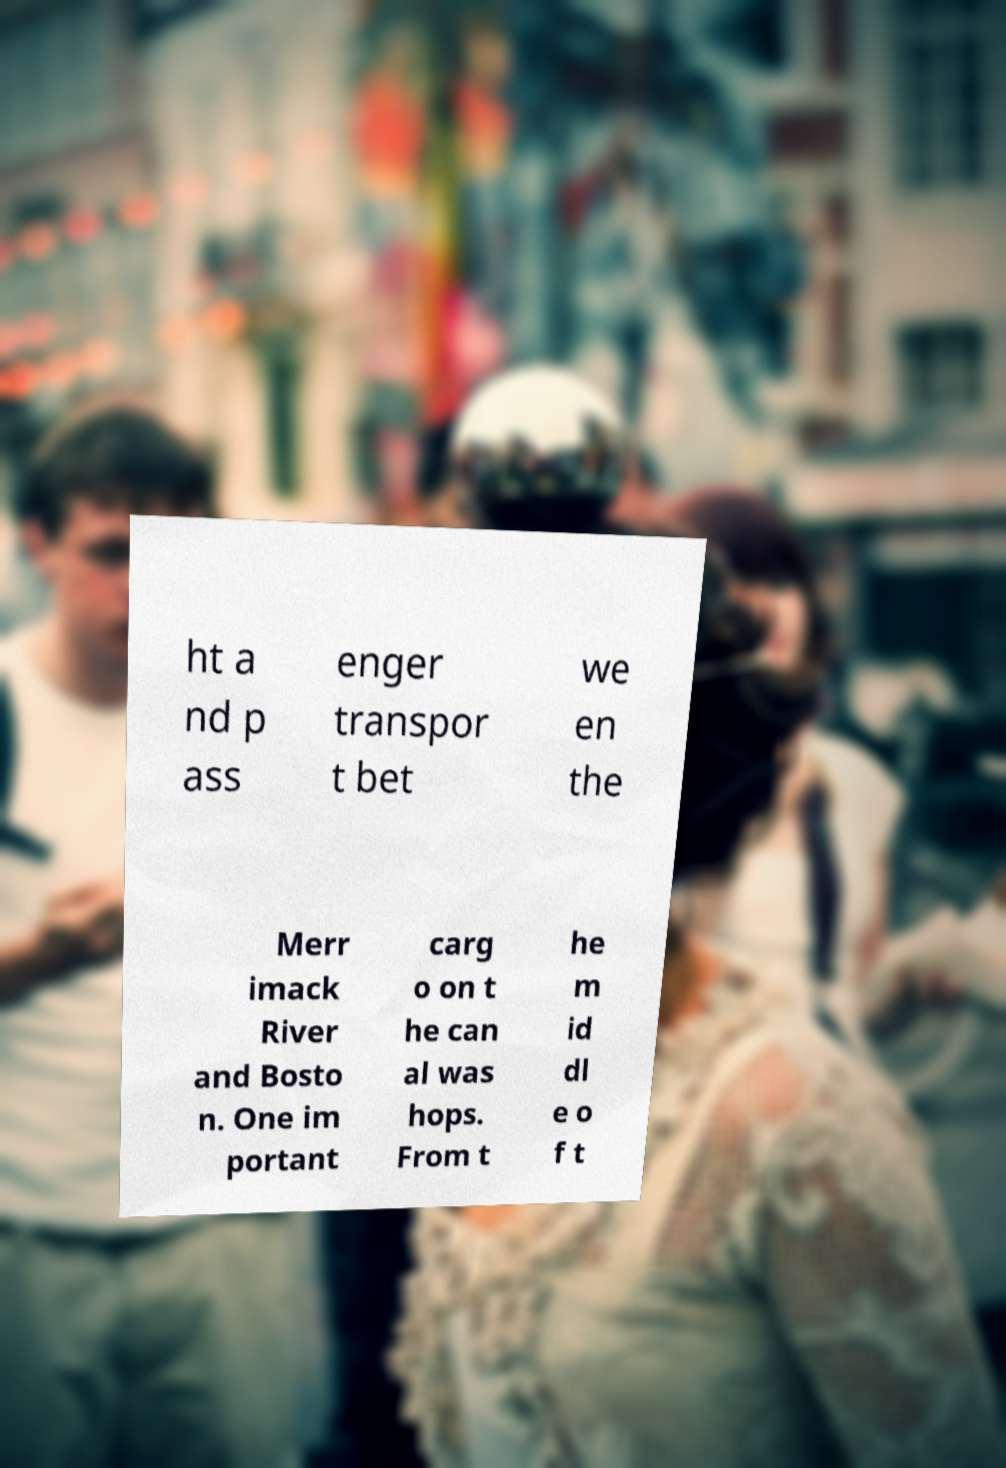Can you accurately transcribe the text from the provided image for me? ht a nd p ass enger transpor t bet we en the Merr imack River and Bosto n. One im portant carg o on t he can al was hops. From t he m id dl e o f t 